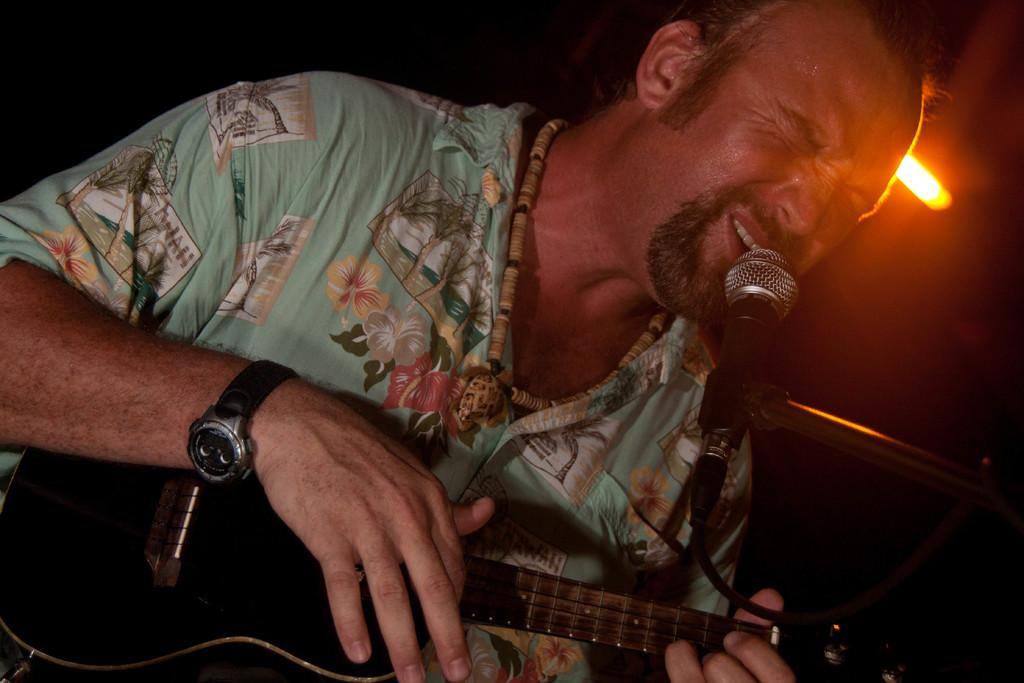What is the man in the image doing? The man is playing a guitar and singing. How is the man amplifying his voice in the image? The man is using a microphone. What can be seen in the image that provides illumination? There is a light visible in the image. What type of milk is the man drinking from the pet's bowl in the image? There is no milk or pet's bowl present in the image; the man is playing a guitar, singing, and using a microphone. 